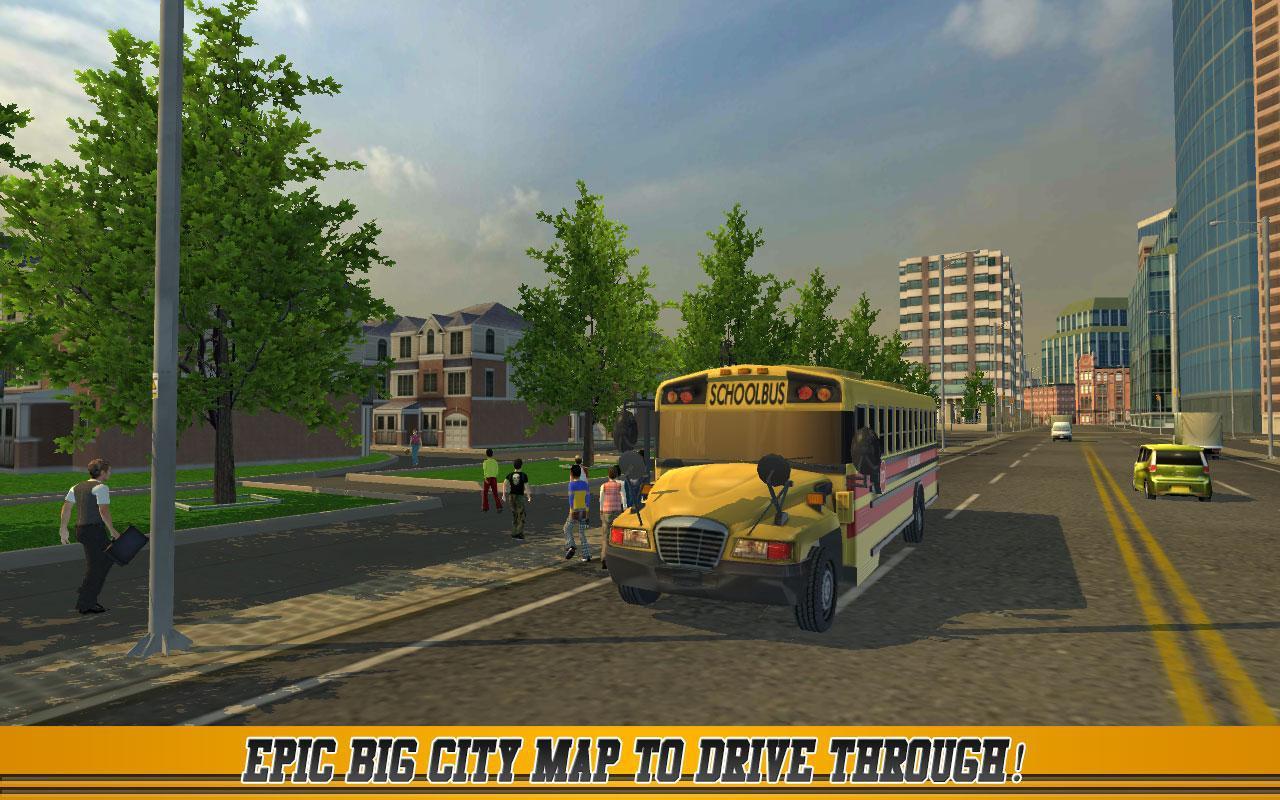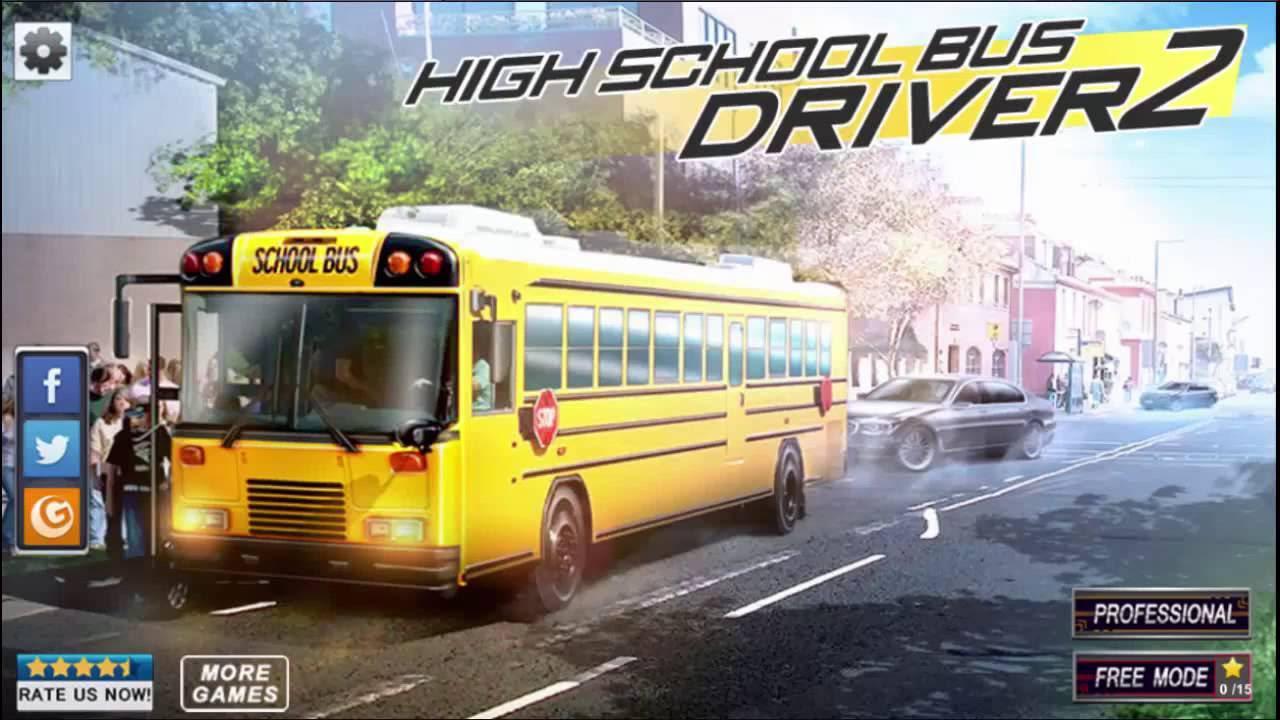The first image is the image on the left, the second image is the image on the right. Given the left and right images, does the statement "In the image to the right, at least one person is standing in front of the open door to the bus." hold true? Answer yes or no. Yes. The first image is the image on the left, the second image is the image on the right. For the images displayed, is the sentence "One image shows one forward-facing flat-fronted bus with at least one person standing at the left, door side, and the other image shows a forward-facing non-flat-front bus with at least one person standing at the left, door side." factually correct? Answer yes or no. Yes. 